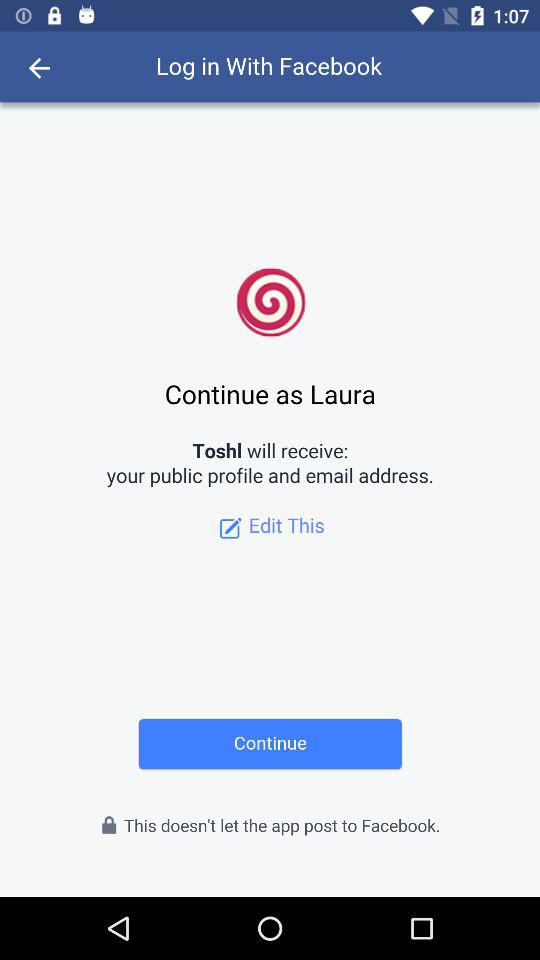What's the name of the user by whom the application can be continued? The name of the user is Laura. 